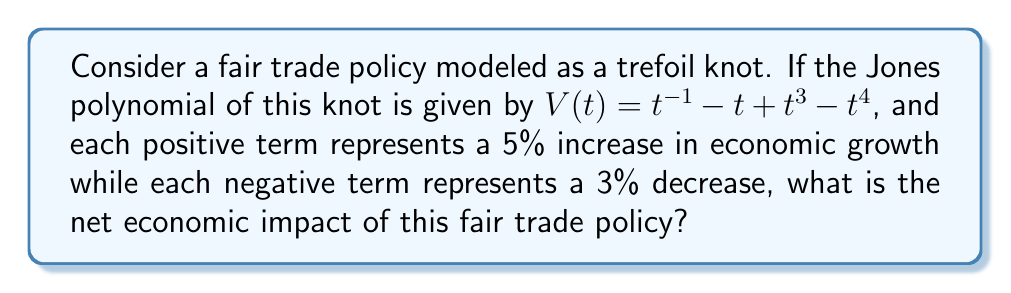Help me with this question. Let's approach this step-by-step:

1) The Jones polynomial of the trefoil knot is given as:
   $V(t) = t^{-1} - t + t^3 - t^4$

2) We need to count the positive and negative terms:
   Positive terms: $t^{-1}$, $t^3$
   Negative terms: $-t$, $-t^4$

3) Each positive term represents a 5% increase in economic growth:
   Number of positive terms = 2
   Total positive impact = $2 \times 5\% = 10\%$

4) Each negative term represents a 3% decrease in economic growth:
   Number of negative terms = 2
   Total negative impact = $2 \times 3\% = 6\%$

5) To find the net economic impact, we subtract the negative impact from the positive impact:
   Net impact = Positive impact - Negative impact
               = $10\% - 6\% = 4\%$

Therefore, the net economic impact of this fair trade policy is a 4% increase in economic growth.
Answer: 4% increase 